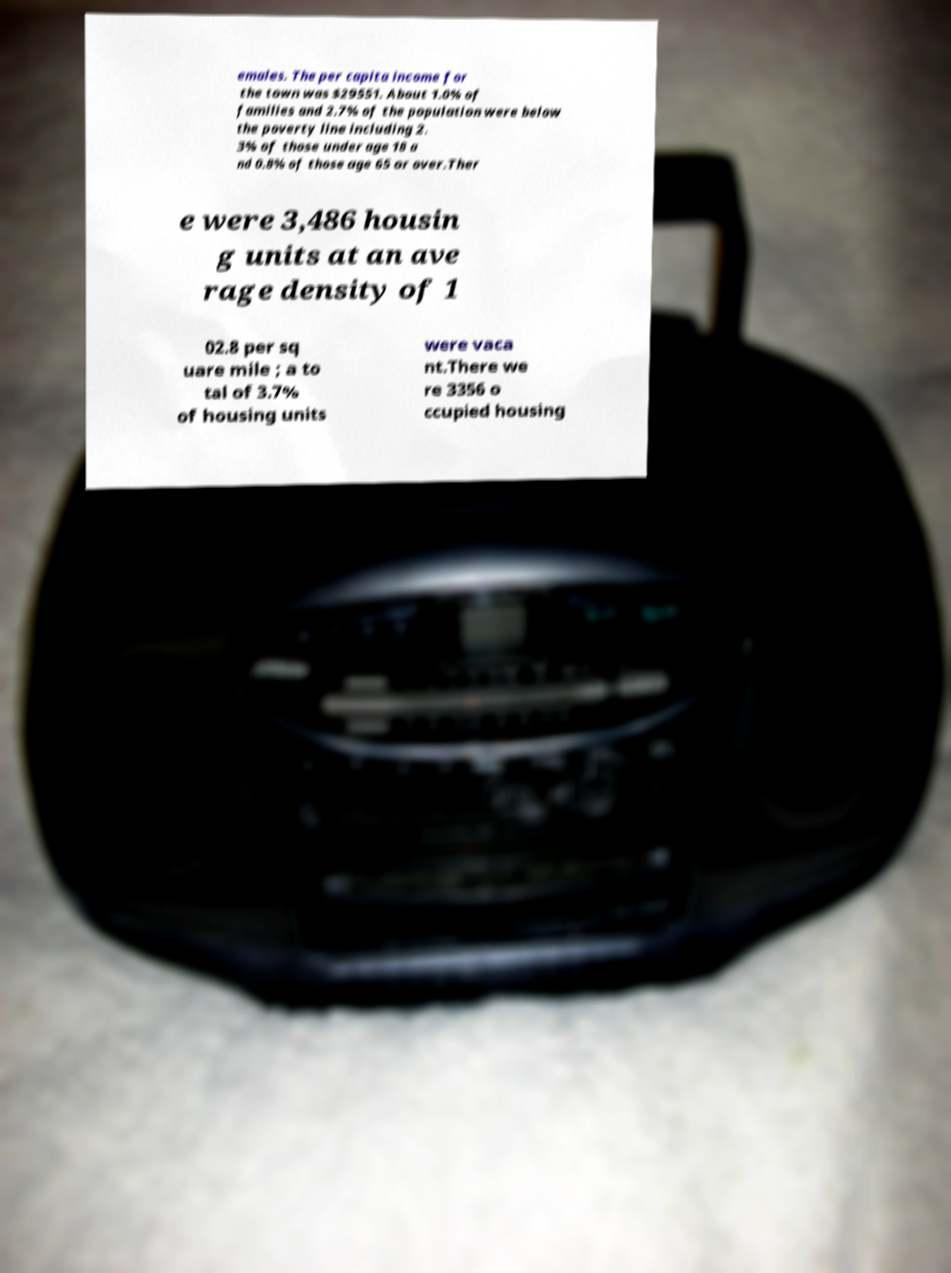Can you read and provide the text displayed in the image?This photo seems to have some interesting text. Can you extract and type it out for me? emales. The per capita income for the town was $29551. About 1.0% of families and 2.7% of the population were below the poverty line including 2. 3% of those under age 18 a nd 0.8% of those age 65 or over.Ther e were 3,486 housin g units at an ave rage density of 1 02.8 per sq uare mile ; a to tal of 3.7% of housing units were vaca nt.There we re 3356 o ccupied housing 